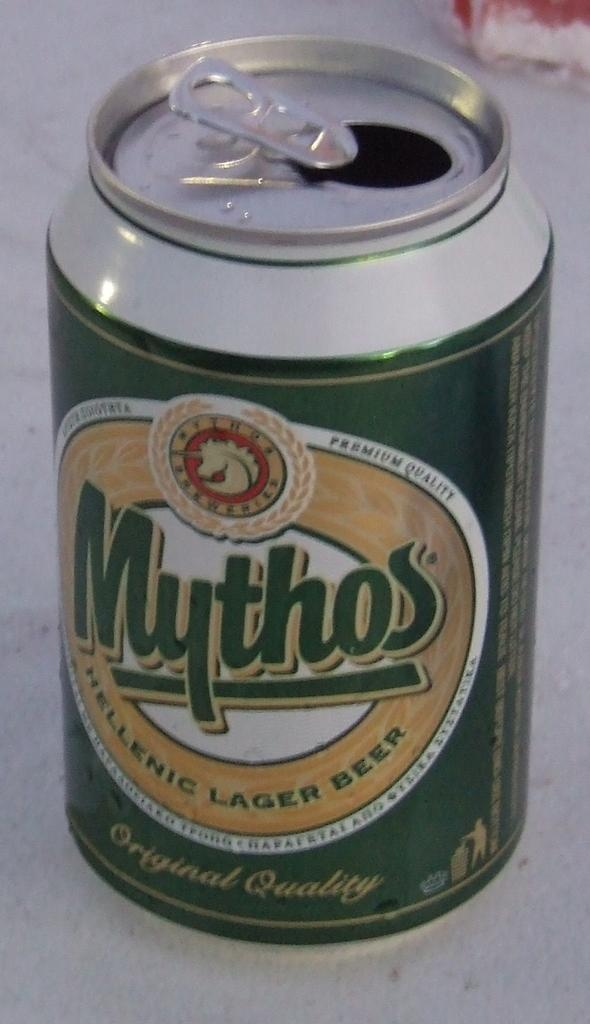<image>
Create a compact narrative representing the image presented. The beer can of Mythos has already been opened. 